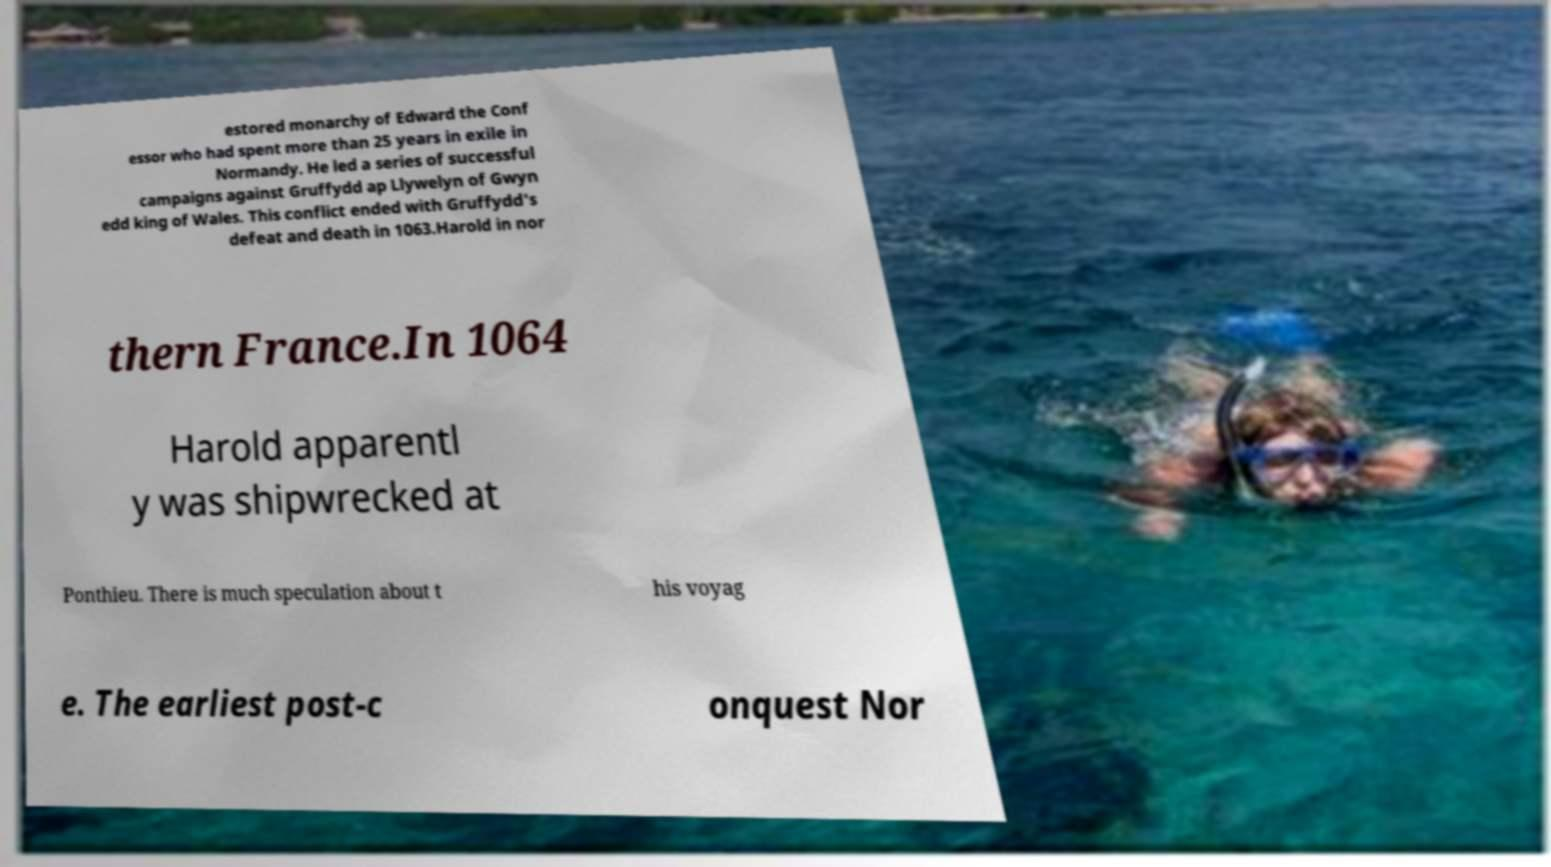Can you read and provide the text displayed in the image?This photo seems to have some interesting text. Can you extract and type it out for me? estored monarchy of Edward the Conf essor who had spent more than 25 years in exile in Normandy. He led a series of successful campaigns against Gruffydd ap Llywelyn of Gwyn edd king of Wales. This conflict ended with Gruffydd's defeat and death in 1063.Harold in nor thern France.In 1064 Harold apparentl y was shipwrecked at Ponthieu. There is much speculation about t his voyag e. The earliest post-c onquest Nor 